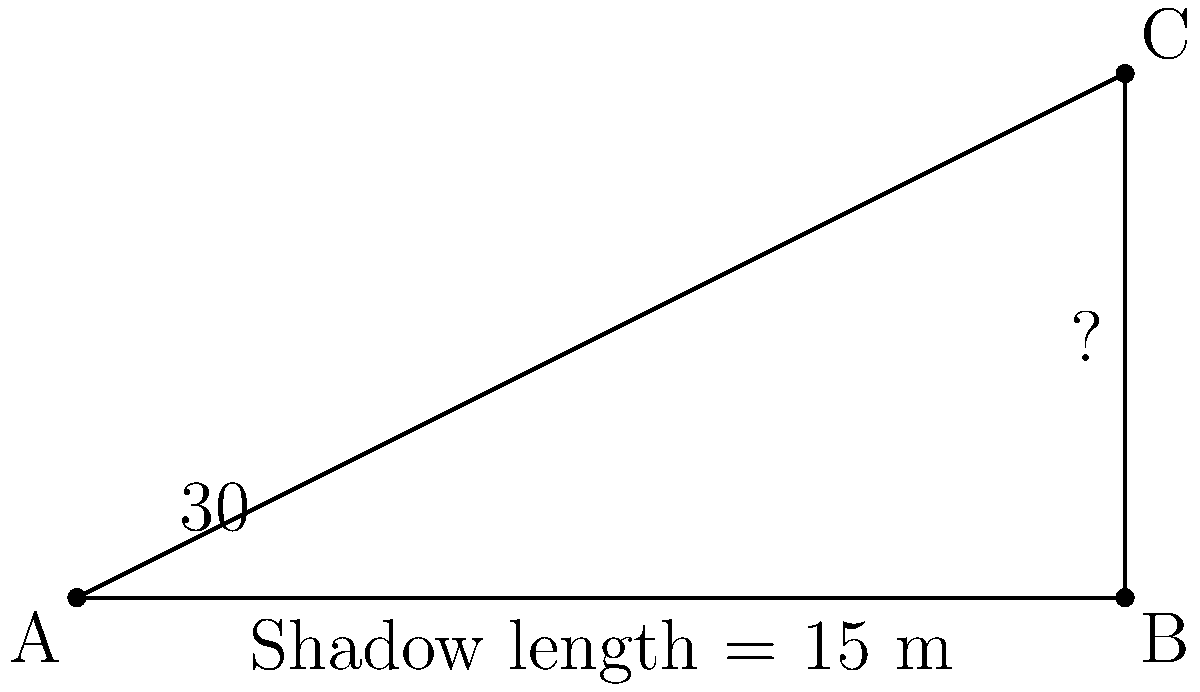At the Great Obelisk of Axum, an archaeologist measures the shadow cast by the obelisk to be 15 meters long when the angle of elevation of the sun is 30°. Using this information, calculate the height of the obelisk. To solve this problem, we'll use trigonometry. Let's approach this step-by-step:

1) First, let's identify what we know:
   - The shadow length is 15 meters
   - The angle of elevation of the sun is 30°

2) We can use the tangent function to find the height. In a right triangle:
   $\tan(\theta) = \frac{\text{opposite}}{\text{adjacent}}$

3) In our case:
   - The angle $\theta$ is 30°
   - The adjacent side is the shadow length (15 m)
   - The opposite side is the height of the obelisk (what we're looking for)

4) Let's call the height $h$. We can write:
   $\tan(30°) = \frac{h}{15}$

5) To solve for $h$, we multiply both sides by 15:
   $15 \cdot \tan(30°) = h$

6) Now, we need to calculate this:
   - $\tan(30°) = \frac{1}{\sqrt{3}} \approx 0.577$
   - $h = 15 \cdot 0.577 = 8.66$ meters

7) Rounding to the nearest centimeter:
   $h \approx 8.66$ meters
Answer: 8.66 meters 